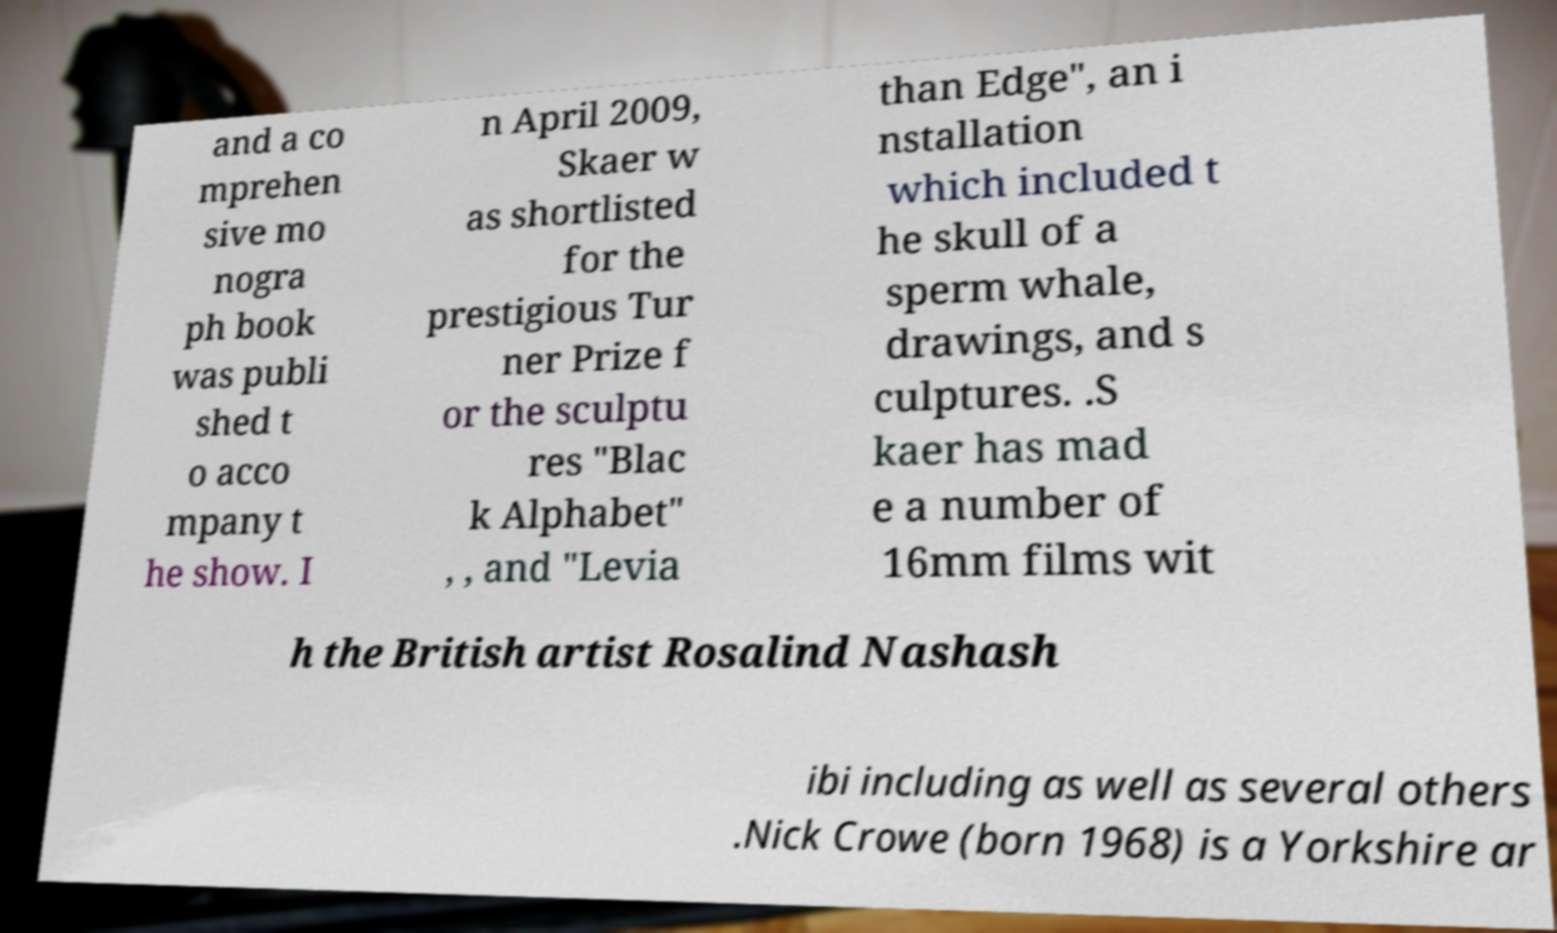Could you assist in decoding the text presented in this image and type it out clearly? and a co mprehen sive mo nogra ph book was publi shed t o acco mpany t he show. I n April 2009, Skaer w as shortlisted for the prestigious Tur ner Prize f or the sculptu res "Blac k Alphabet" , , and "Levia than Edge", an i nstallation which included t he skull of a sperm whale, drawings, and s culptures. .S kaer has mad e a number of 16mm films wit h the British artist Rosalind Nashash ibi including as well as several others .Nick Crowe (born 1968) is a Yorkshire ar 